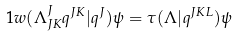<formula> <loc_0><loc_0><loc_500><loc_500>\ 1 w ( \Lambda ^ { J } _ { J K } q ^ { J K } | q ^ { J } ) \psi = \tau ( \Lambda | q ^ { J K L } ) \psi</formula> 